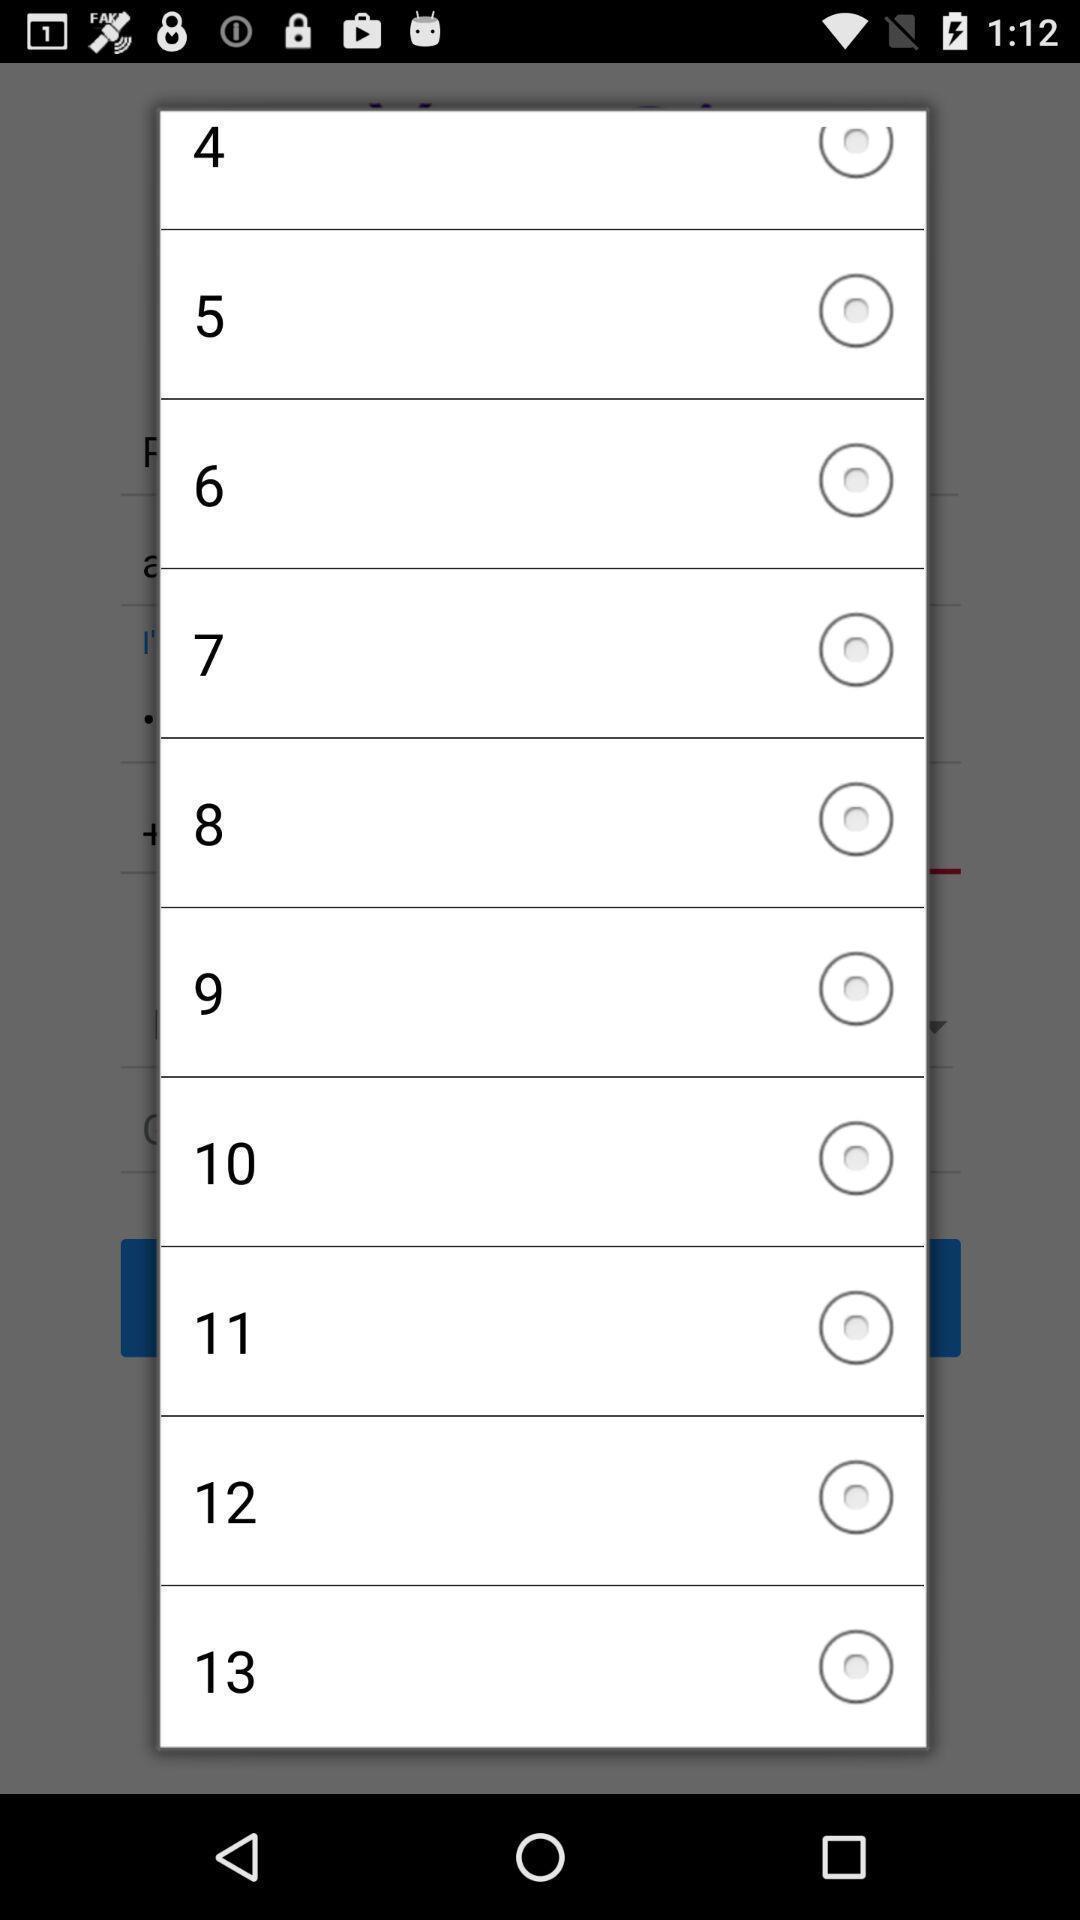Describe this image in words. Popup displaying to select a option. 